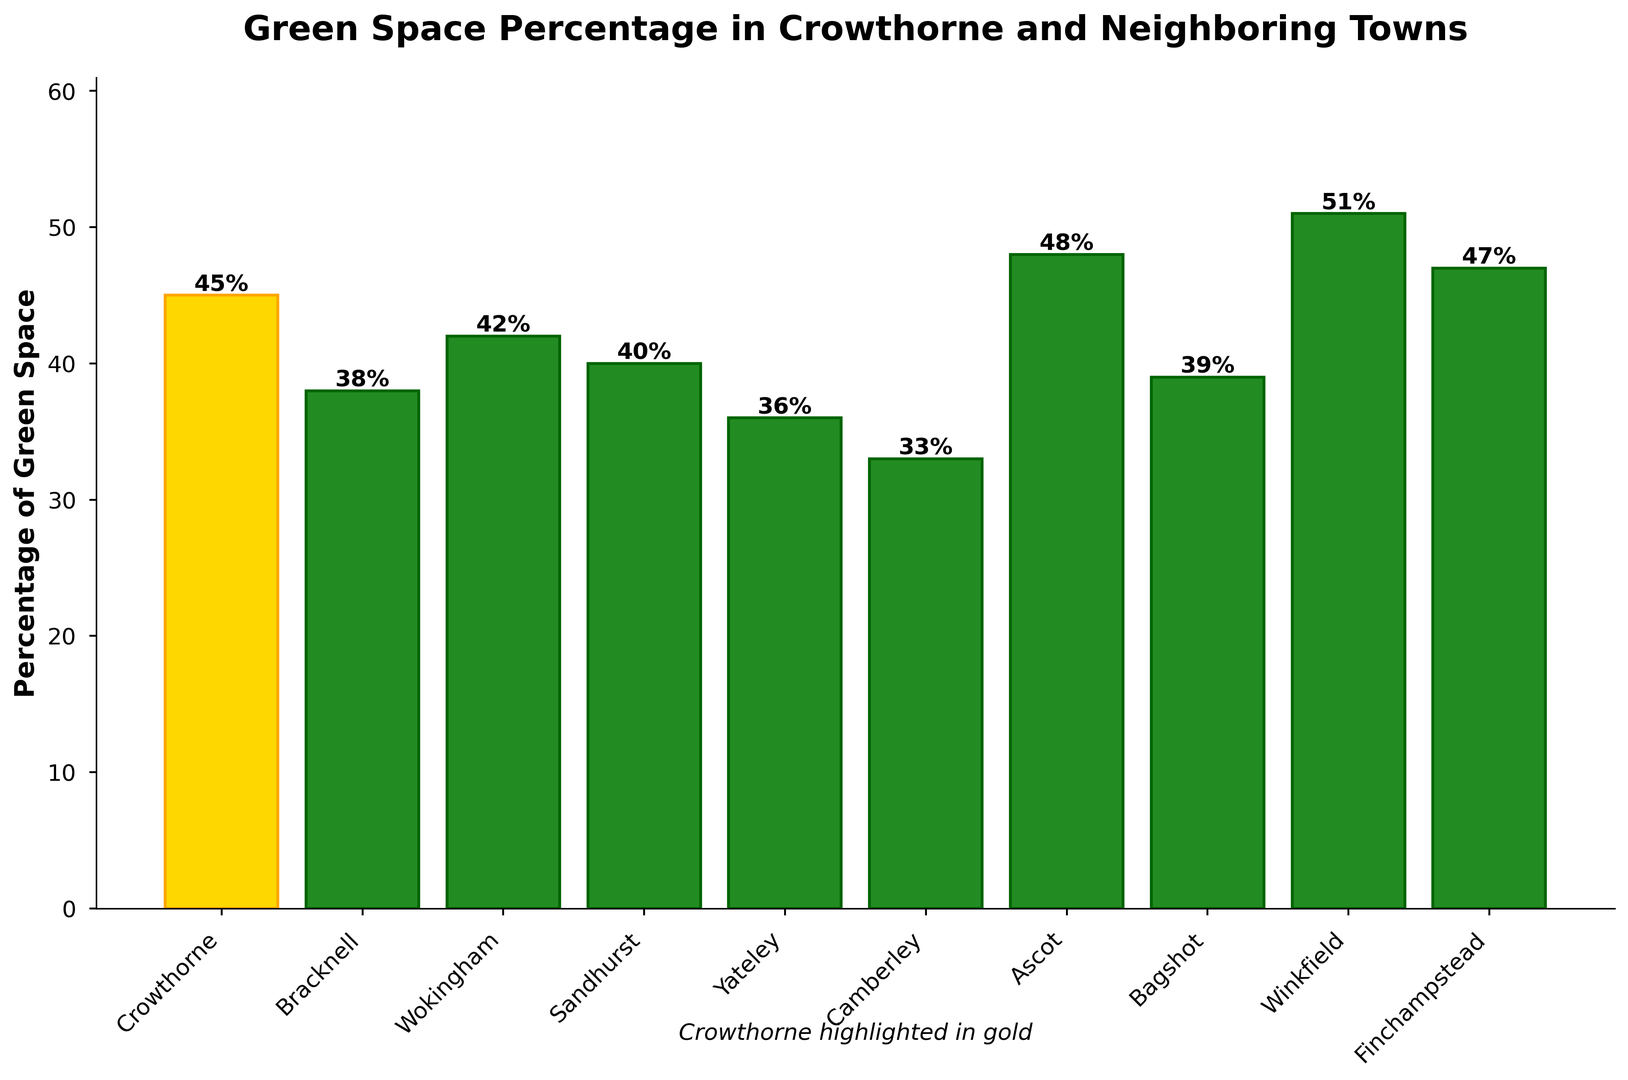What's the percentage of green space in Crowthorne? The percentage of green space in Crowthorne is directly stated in the bar labeled "Crowthorne" on the chart.
Answer: 45% Which town has the highest percentage of green space? The town with the highest percentage of green space is represented by the tallest bar on the chart. In this case, it's the bar labeled "Winkfield".
Answer: Winkfield How does Crowthorne’s percentage of green space compare to Yateley's? Compare the height of the bars for Crowthorne and Yateley. The Crowthorne bar is labeled with 45%, while Yateley's bar is labeled with 36%.
Answer: Crowthorne has a higher percentage What is the average percentage of green space across all the towns listed? Sum the percentages of all towns and divide by the number of towns. (45+38+42+40+36+33+48+39+51+47)/10 = 41.9
Answer: 41.9% Is the percentage of green space in Sandhurst above or below the average percentage of green space across all towns? The average percentage is 41.9%. Sandhurst's percentage is 40%. Since 40% is less than 41.9%, it is below the average.
Answer: Below What is the difference between the percentages of green space in Crowthorne and Ascot? Subtract the percentage in Crowthorne from the percentage in Ascot: 48% - 45% = 3%
Answer: 3% Which town has a percentage of green space closest to that of Wokingham? Find the bar nearest in height to Wokingham’s bar, which is at 42%. Bracknell at 38% and Sandhurst at 40% are both nearby, with Sandhurst being closer.
Answer: Sandhurst If we group the towns into two categories, those with ≥45% green space and those with <45%, which category has more towns? Count the towns in each category. Towns with ≥45%: Crowthorne, Ascot, Winkfield, Finchampstead (4 towns); Towns with <45%: Bracknell, Wokingham, Sandhurst, Yateley, Camberley, Bagshot (6 towns).
Answer: <45% Which towns have between 35% and 45% green space? Identify the bars labeled with percentages between 35% and 45%. Bracknell (38%), Wokingham (42%), Sandhurst (40%), Yateley (36%), and Bagshot (39%) fit this range.
Answer: Bracknell, Wokingham, Sandhurst, Yateley, Bagshot What is the combined percentage of green space for Crowthorne and Camberley? Add the percentages for Crowthorne and Camberley: 45% + 33% = 78%
Answer: 78% 